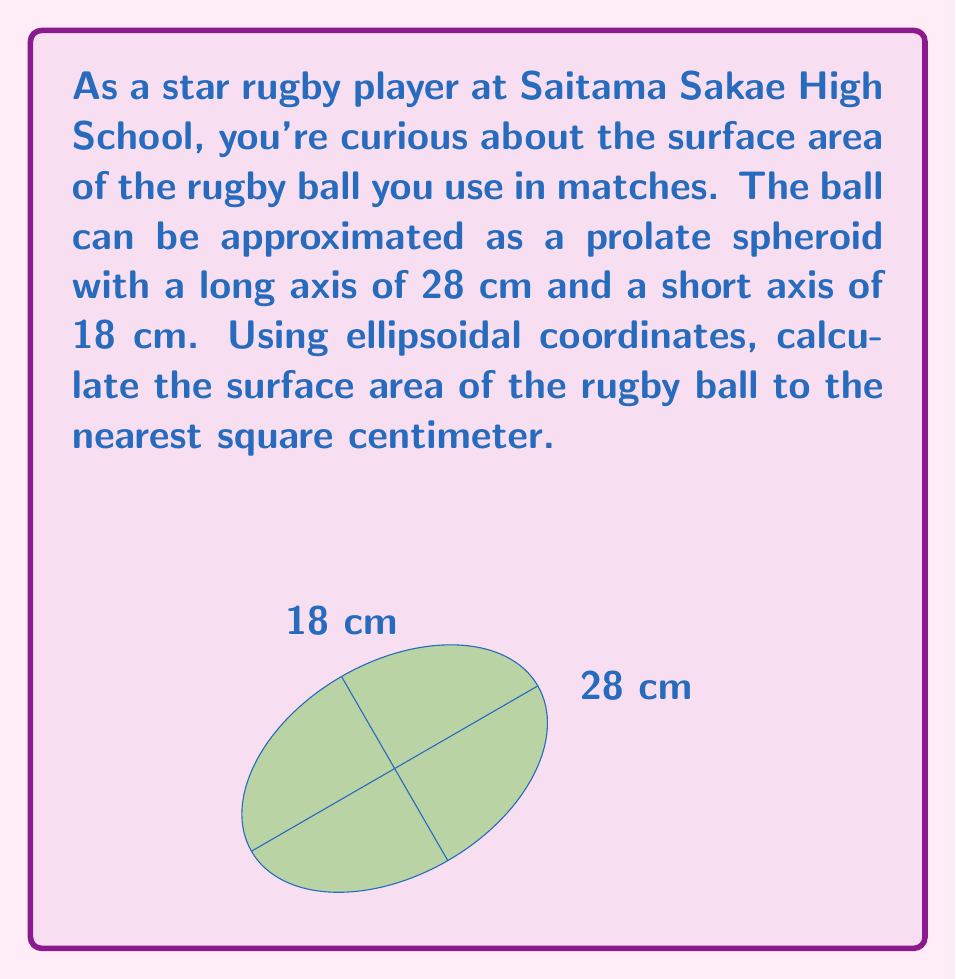Can you answer this question? Let's approach this step-by-step:

1) For a prolate spheroid (where $a > b$), the surface area is given by:

   $$A = 2\pi b^2 + \frac{2\pi ab}{\sqrt{a^2-b^2}} \sin^{-1}\left(\frac{\sqrt{a^2-b^2}}{a}\right)$$

   where $a$ is the semi-major axis and $b$ is the semi-minor axis.

2) From the given dimensions:
   $a = 28/2 = 14$ cm
   $b = 18/2 = 9$ cm

3) Let's substitute these values:

   $$A = 2\pi(9)^2 + \frac{2\pi(14)(9)}{\sqrt{14^2-9^2}} \sin^{-1}\left(\frac{\sqrt{14^2-9^2}}{14}\right)$$

4) Simplify:
   $$A = 2\pi(81) + \frac{2\pi(126)}{\sqrt{196-81}} \sin^{-1}\left(\frac{\sqrt{115}}{14}\right)$$
   $$A = 162\pi + \frac{252\pi}{\sqrt{115}} \sin^{-1}\left(\frac{\sqrt{115}}{14}\right)$$

5) Calculate:
   $$A \approx 508.94 + 738.65 \times 0.9758$$
   $$A \approx 508.94 + 720.79$$
   $$A \approx 1229.73 \text{ cm}^2$$

6) Rounding to the nearest square centimeter:
   $$A \approx 1230 \text{ cm}^2$$
Answer: 1230 cm² 